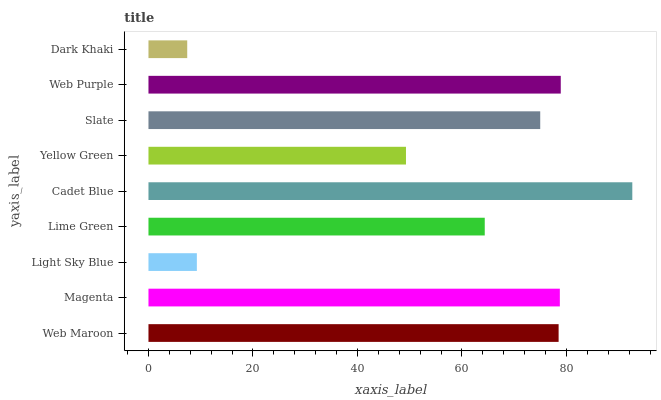Is Dark Khaki the minimum?
Answer yes or no. Yes. Is Cadet Blue the maximum?
Answer yes or no. Yes. Is Magenta the minimum?
Answer yes or no. No. Is Magenta the maximum?
Answer yes or no. No. Is Magenta greater than Web Maroon?
Answer yes or no. Yes. Is Web Maroon less than Magenta?
Answer yes or no. Yes. Is Web Maroon greater than Magenta?
Answer yes or no. No. Is Magenta less than Web Maroon?
Answer yes or no. No. Is Slate the high median?
Answer yes or no. Yes. Is Slate the low median?
Answer yes or no. Yes. Is Light Sky Blue the high median?
Answer yes or no. No. Is Web Purple the low median?
Answer yes or no. No. 